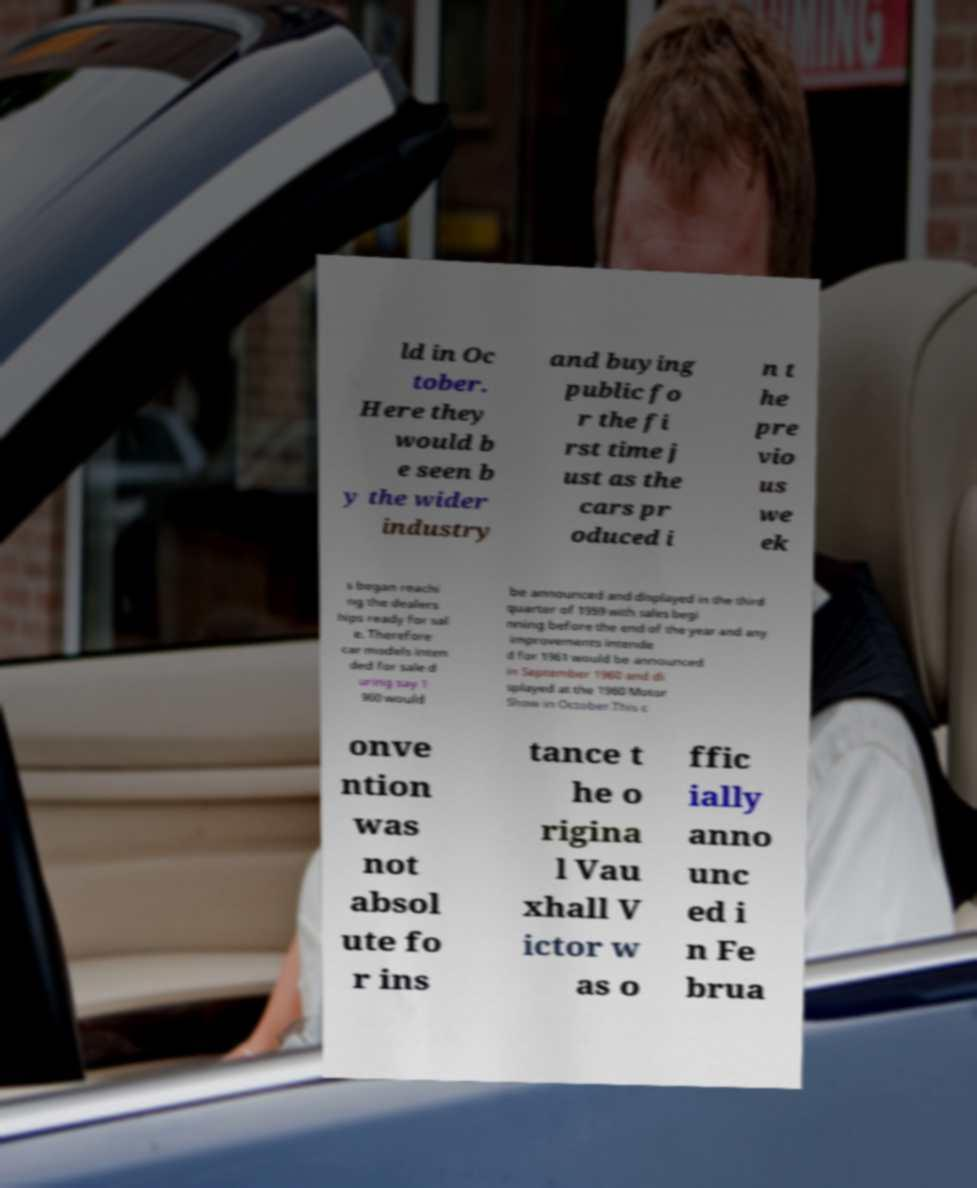Please identify and transcribe the text found in this image. ld in Oc tober. Here they would b e seen b y the wider industry and buying public fo r the fi rst time j ust as the cars pr oduced i n t he pre vio us we ek s began reachi ng the dealers hips ready for sal e. Therefore car models inten ded for sale d uring say 1 960 would be announced and displayed in the third quarter of 1959 with sales begi nning before the end of the year and any improvements intende d for 1961 would be announced in September 1960 and di splayed at the 1960 Motor Show in October.This c onve ntion was not absol ute fo r ins tance t he o rigina l Vau xhall V ictor w as o ffic ially anno unc ed i n Fe brua 